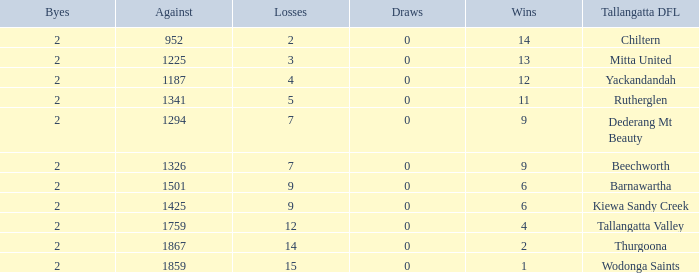What are the draws when wins are fwewer than 9 and byes fewer than 2? 0.0. 